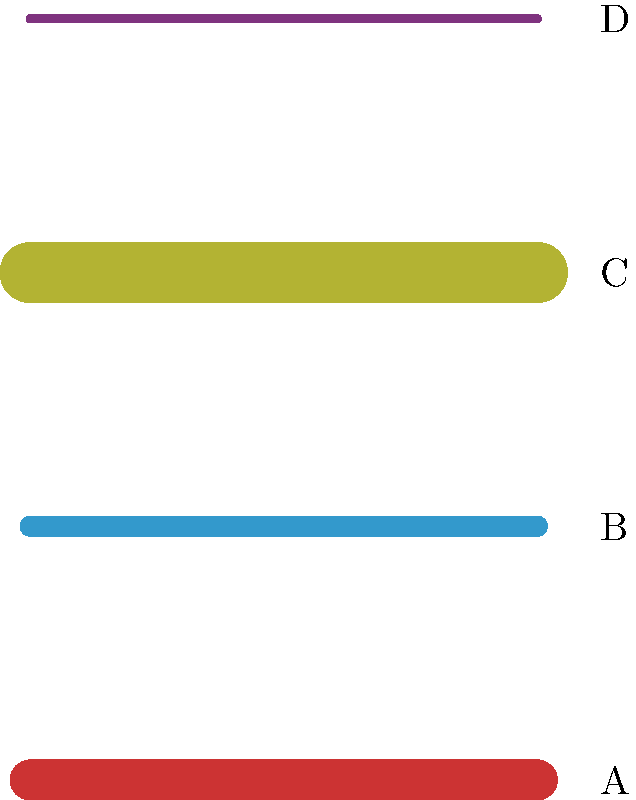As an ASU art student inspired by Steven Tepper's work on artistic techniques, identify which of the brush strokes (A, B, C, or D) in the image above best represents the "impasto" technique often used in oil painting. To answer this question, let's break down the characteristics of each brush stroke and compare them to the impasto technique:

1. Impasto technique: This is a painting technique where paint is applied very thickly to the canvas, creating a textured, three-dimensional effect.

2. Analyzing the brush strokes:
   A: This stroke is thick and bold, showing a substantial amount of paint.
   B: This stroke is medium in thickness, showing a moderate amount of paint.
   C: This stroke is the thickest, showing the most substantial amount of paint.
   D: This stroke is very thin, showing minimal paint application.

3. Comparing to impasto:
   The impasto technique is characterized by its thick application of paint, creating a raised surface on the canvas.

4. Conclusion:
   Stroke C best represents the impasto technique due to its notably thick application, which would create the most prominent raised texture on a canvas.
Answer: C 